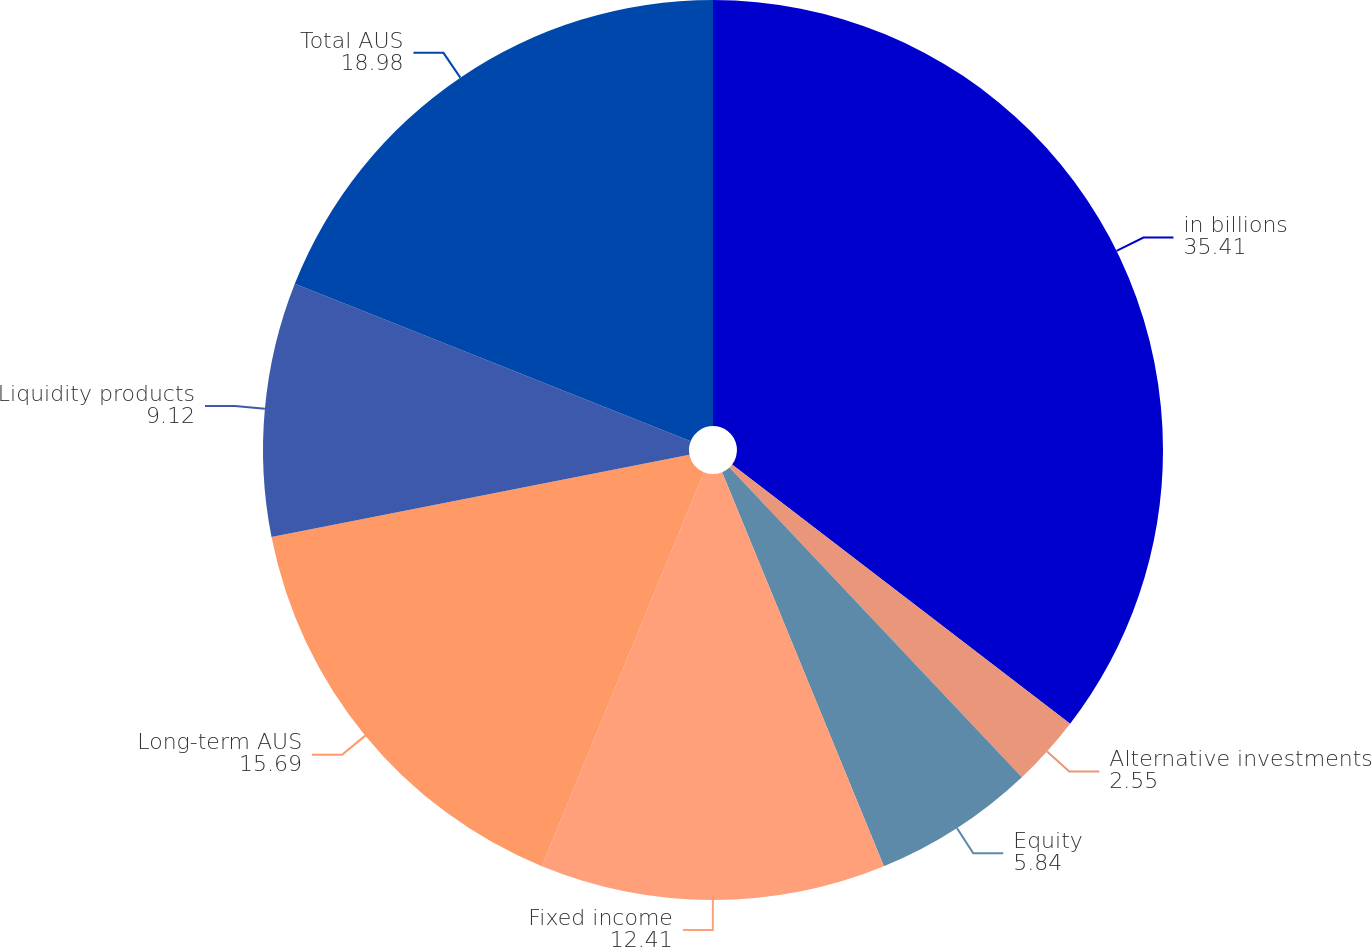Convert chart to OTSL. <chart><loc_0><loc_0><loc_500><loc_500><pie_chart><fcel>in billions<fcel>Alternative investments<fcel>Equity<fcel>Fixed income<fcel>Long-term AUS<fcel>Liquidity products<fcel>Total AUS<nl><fcel>35.41%<fcel>2.55%<fcel>5.84%<fcel>12.41%<fcel>15.69%<fcel>9.12%<fcel>18.98%<nl></chart> 